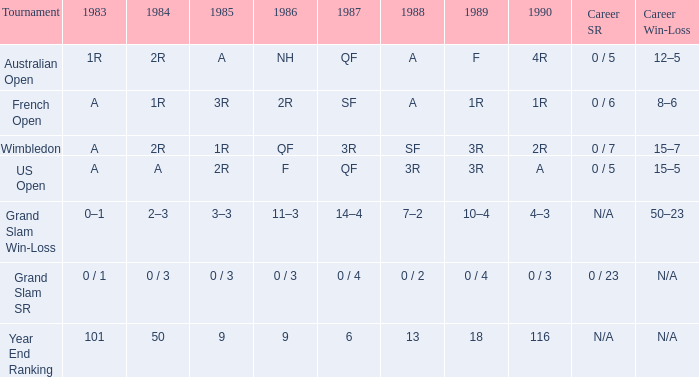What is the result in 1985 when the career win-loss is n/a, and 0 / 23 as the career SR? 0 / 3. 